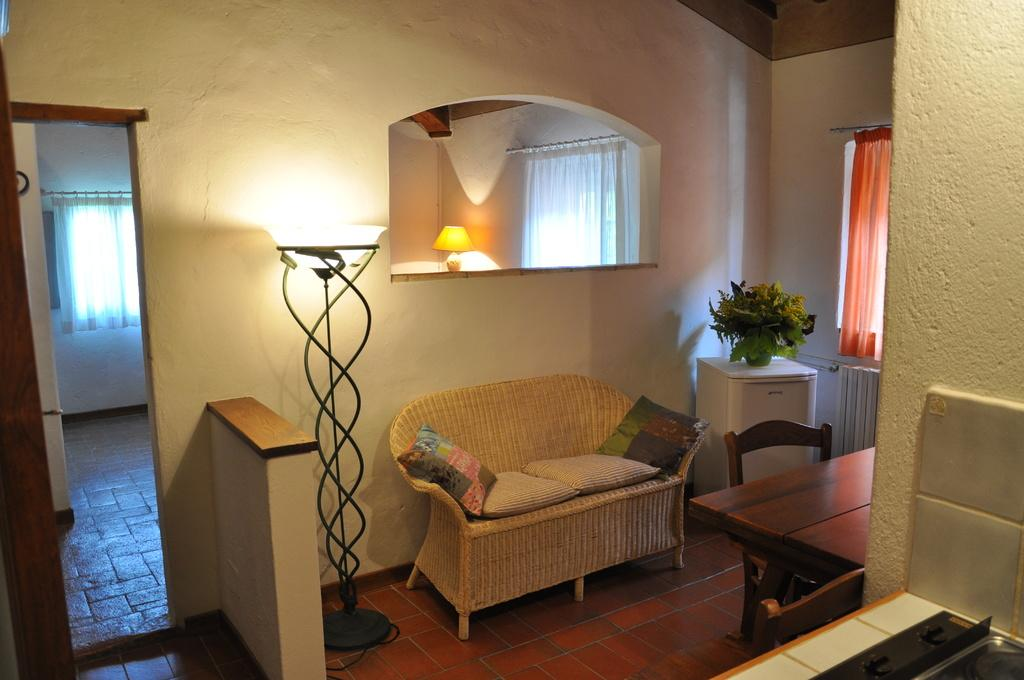What type of room is shown in the image? The image depicts a living room. What type of window treatment is present in the living room? There are curtains in the living room. What type of lighting is present in the living room? There are lamps in the living room. What type of furniture is present in the living room for seating? There are chairs and sofas in the living room. What type of decorative item is present in the living room? There are cushions in the living room. What type of greenery is present in the living room? There is a house plant in the living room. Reasoning: Let'ing: Let's think step by step in order to produce the conversation. We start by identifying the type of room shown in the image, which is a living room. Then, we describe the various elements present in the living room, such as curtains, lamps, furniture, decorative items, and greenery. Each question is designed to elicit a specific detail about the living room that is known from the provided facts. Absurd Question/Answer: What type of joke is being told by the face on the wall in the living room? There is no face on the wall in the living room, so no joke can be observed. 